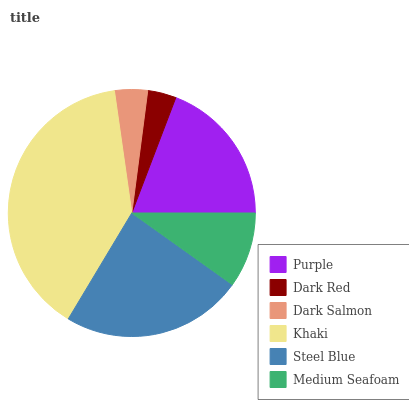Is Dark Red the minimum?
Answer yes or no. Yes. Is Khaki the maximum?
Answer yes or no. Yes. Is Dark Salmon the minimum?
Answer yes or no. No. Is Dark Salmon the maximum?
Answer yes or no. No. Is Dark Salmon greater than Dark Red?
Answer yes or no. Yes. Is Dark Red less than Dark Salmon?
Answer yes or no. Yes. Is Dark Red greater than Dark Salmon?
Answer yes or no. No. Is Dark Salmon less than Dark Red?
Answer yes or no. No. Is Purple the high median?
Answer yes or no. Yes. Is Medium Seafoam the low median?
Answer yes or no. Yes. Is Dark Red the high median?
Answer yes or no. No. Is Khaki the low median?
Answer yes or no. No. 